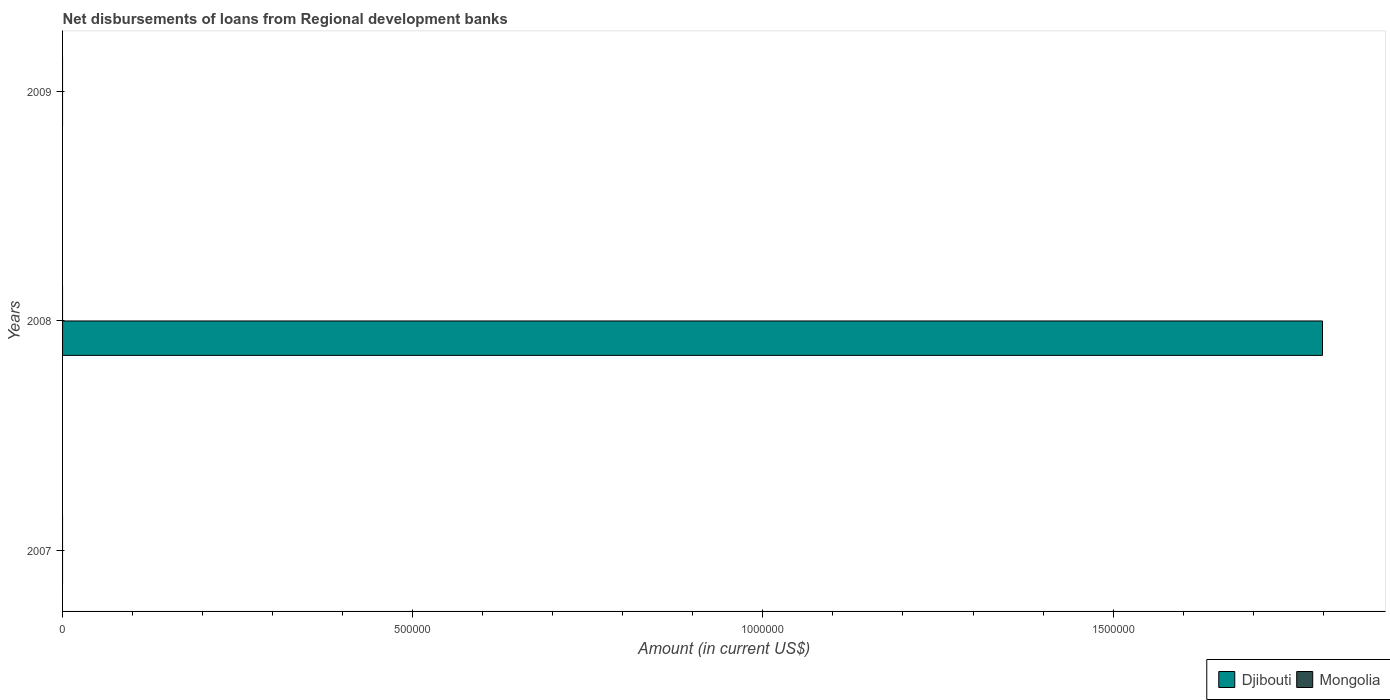Are the number of bars per tick equal to the number of legend labels?
Your response must be concise. No. How many bars are there on the 2nd tick from the top?
Offer a very short reply. 1. What is the label of the 2nd group of bars from the top?
Provide a short and direct response. 2008. What is the amount of disbursements of loans from regional development banks in Djibouti in 2009?
Provide a succinct answer. 0. Across all years, what is the maximum amount of disbursements of loans from regional development banks in Djibouti?
Offer a terse response. 1.80e+06. What is the total amount of disbursements of loans from regional development banks in Djibouti in the graph?
Make the answer very short. 1.80e+06. What is the difference between the amount of disbursements of loans from regional development banks in Mongolia in 2008 and the amount of disbursements of loans from regional development banks in Djibouti in 2007?
Make the answer very short. 0. What is the average amount of disbursements of loans from regional development banks in Djibouti per year?
Provide a short and direct response. 6.00e+05. What is the difference between the highest and the lowest amount of disbursements of loans from regional development banks in Djibouti?
Provide a short and direct response. 1.80e+06. How many bars are there?
Keep it short and to the point. 1. Does the graph contain grids?
Ensure brevity in your answer.  No. Where does the legend appear in the graph?
Your response must be concise. Bottom right. How many legend labels are there?
Offer a terse response. 2. How are the legend labels stacked?
Keep it short and to the point. Horizontal. What is the title of the graph?
Provide a succinct answer. Net disbursements of loans from Regional development banks. What is the label or title of the X-axis?
Provide a short and direct response. Amount (in current US$). What is the label or title of the Y-axis?
Give a very brief answer. Years. What is the Amount (in current US$) in Djibouti in 2007?
Make the answer very short. 0. What is the Amount (in current US$) in Mongolia in 2007?
Provide a succinct answer. 0. What is the Amount (in current US$) of Djibouti in 2008?
Offer a terse response. 1.80e+06. What is the Amount (in current US$) of Djibouti in 2009?
Keep it short and to the point. 0. What is the Amount (in current US$) in Mongolia in 2009?
Keep it short and to the point. 0. Across all years, what is the maximum Amount (in current US$) of Djibouti?
Make the answer very short. 1.80e+06. What is the total Amount (in current US$) in Djibouti in the graph?
Provide a short and direct response. 1.80e+06. What is the average Amount (in current US$) in Djibouti per year?
Ensure brevity in your answer.  6.00e+05. What is the difference between the highest and the lowest Amount (in current US$) of Djibouti?
Provide a short and direct response. 1.80e+06. 